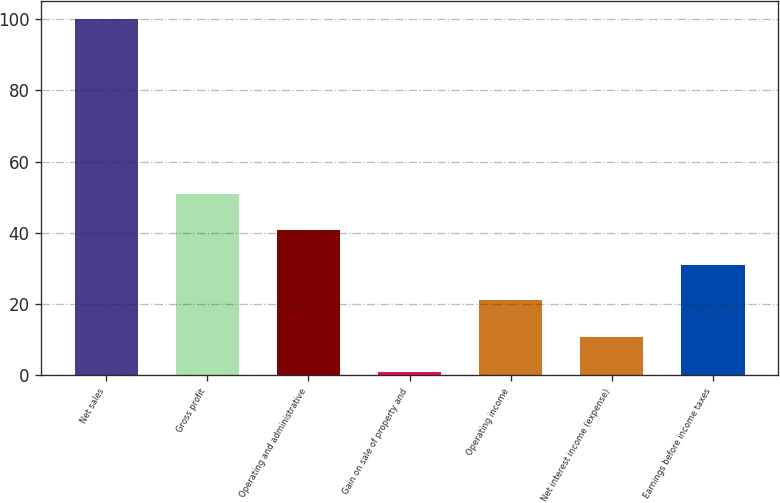Convert chart. <chart><loc_0><loc_0><loc_500><loc_500><bar_chart><fcel>Net sales<fcel>Gross profit<fcel>Operating and administrative<fcel>Gain on sale of property and<fcel>Operating income<fcel>Net interest income (expense)<fcel>Earnings before income taxes<nl><fcel>100<fcel>50.83<fcel>40.92<fcel>0.92<fcel>21.1<fcel>10.83<fcel>31.01<nl></chart> 